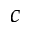<formula> <loc_0><loc_0><loc_500><loc_500>c</formula> 